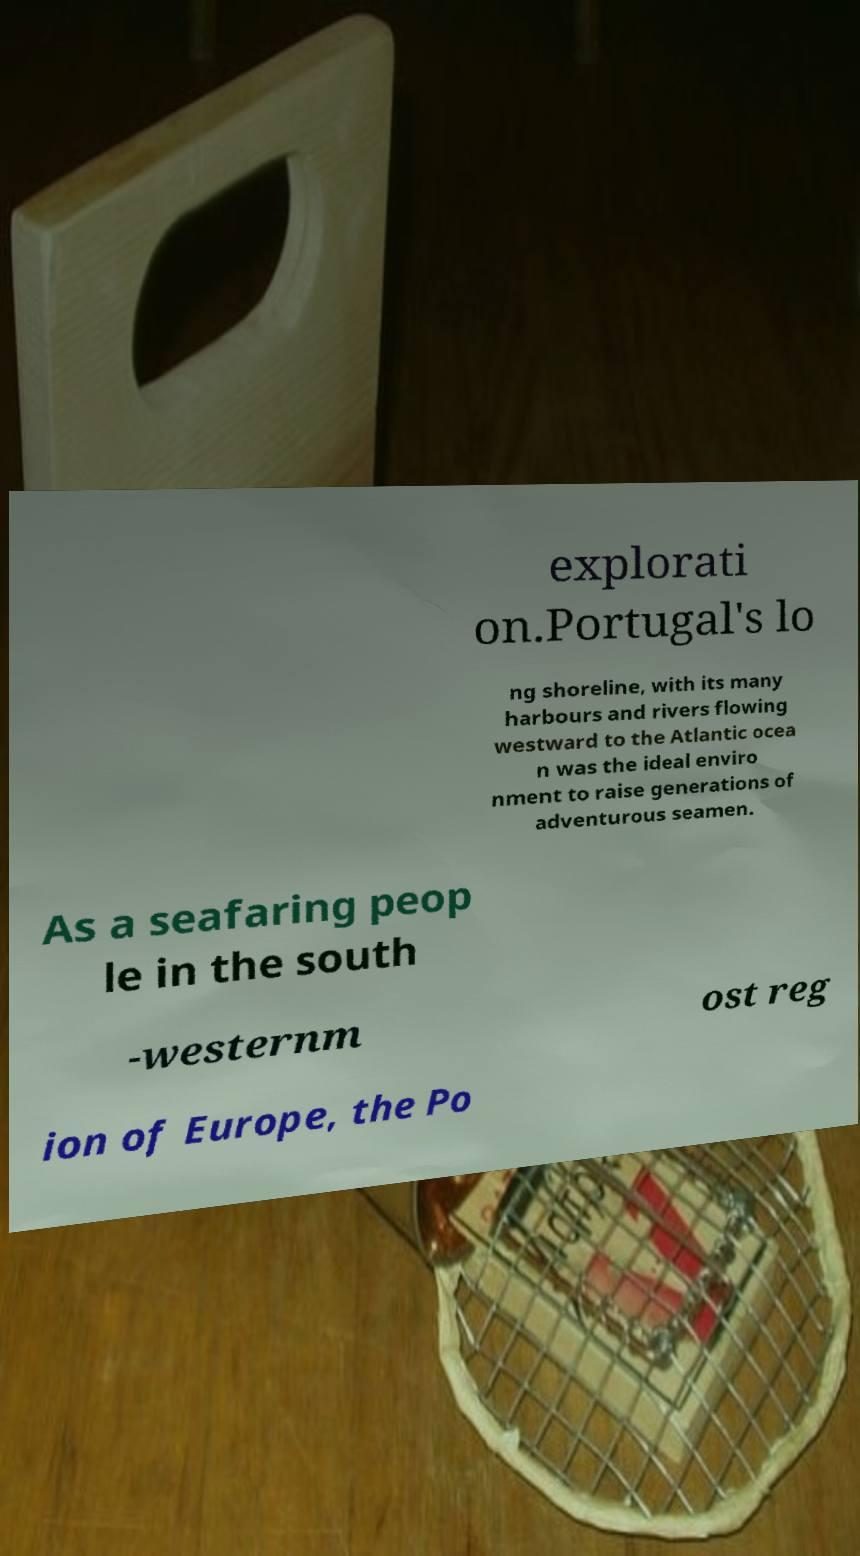Could you assist in decoding the text presented in this image and type it out clearly? explorati on.Portugal's lo ng shoreline, with its many harbours and rivers flowing westward to the Atlantic ocea n was the ideal enviro nment to raise generations of adventurous seamen. As a seafaring peop le in the south -westernm ost reg ion of Europe, the Po 